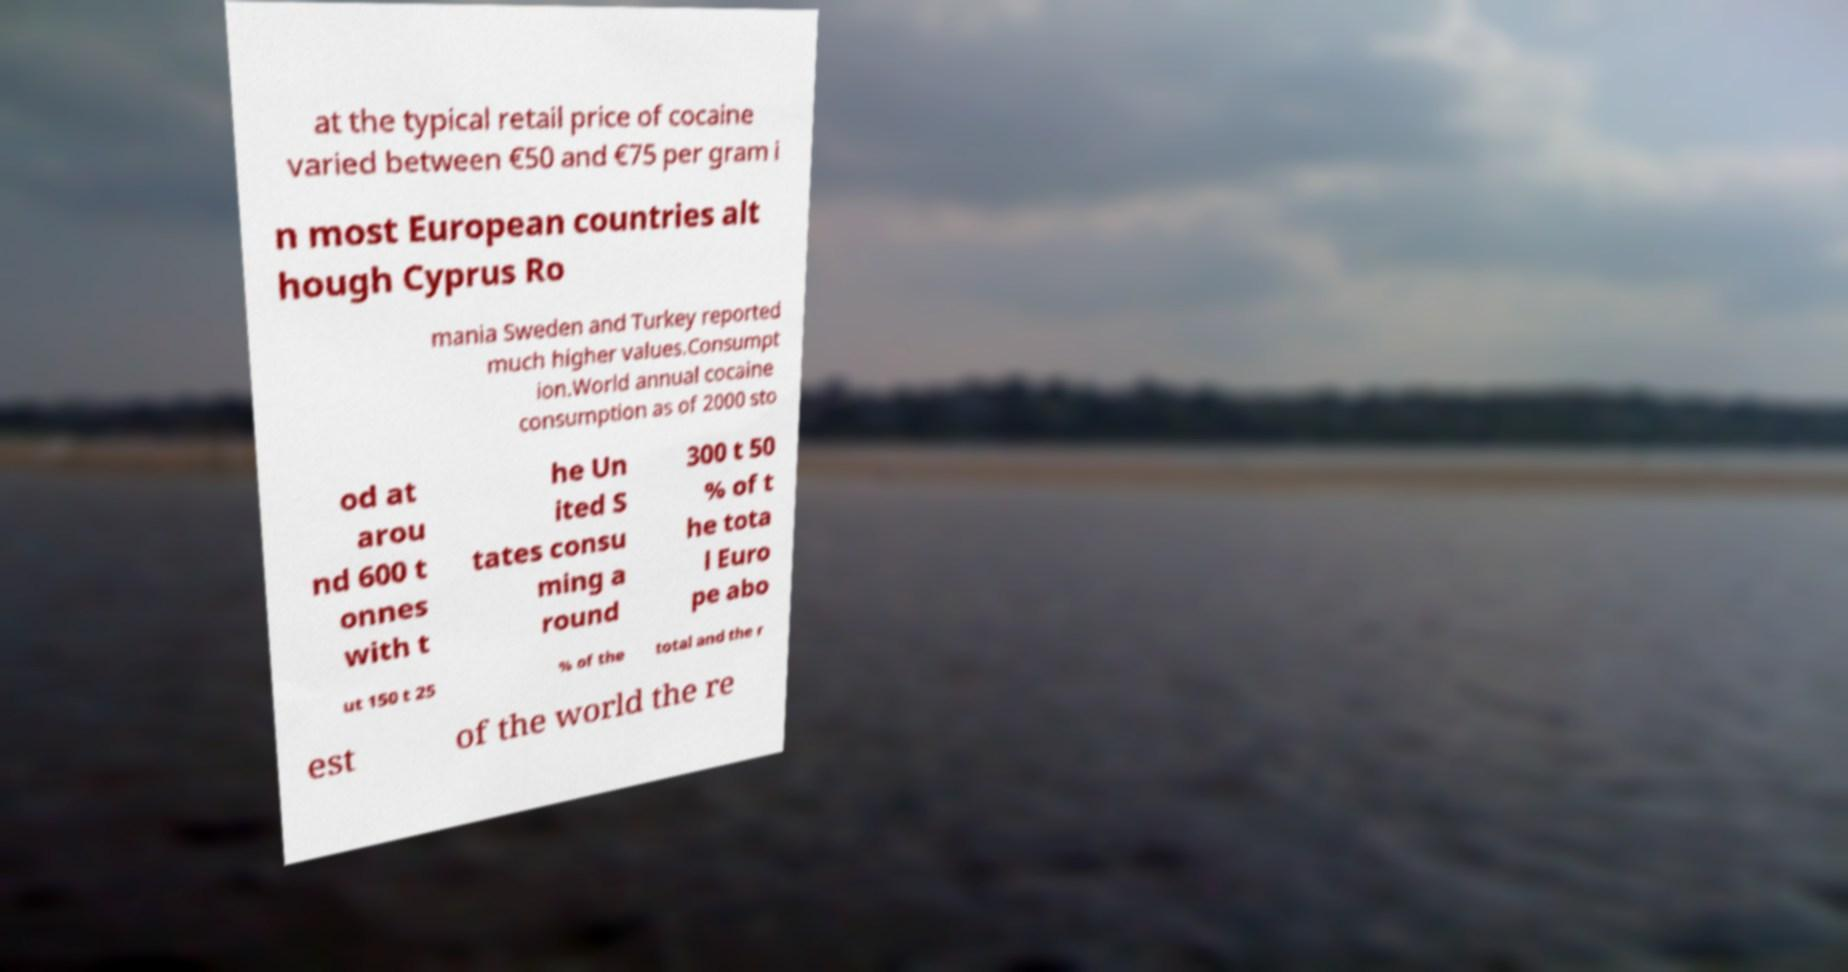Could you extract and type out the text from this image? at the typical retail price of cocaine varied between €50 and €75 per gram i n most European countries alt hough Cyprus Ro mania Sweden and Turkey reported much higher values.Consumpt ion.World annual cocaine consumption as of 2000 sto od at arou nd 600 t onnes with t he Un ited S tates consu ming a round 300 t 50 % of t he tota l Euro pe abo ut 150 t 25 % of the total and the r est of the world the re 